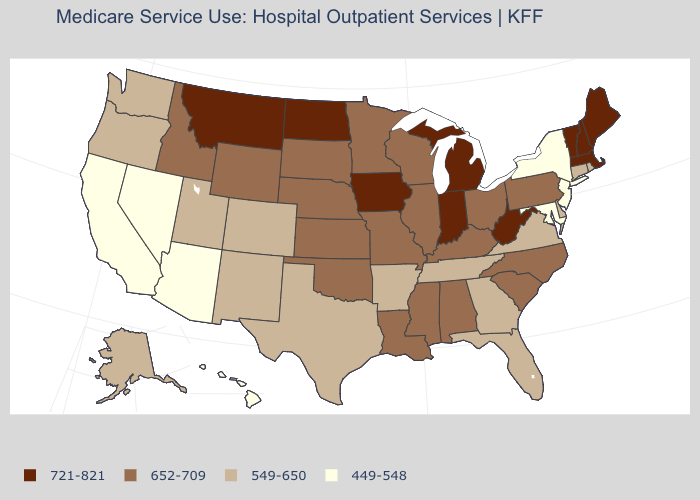Among the states that border Vermont , does New Hampshire have the highest value?
Short answer required. Yes. Does the first symbol in the legend represent the smallest category?
Concise answer only. No. Does New Jersey have a lower value than Washington?
Keep it brief. Yes. Name the states that have a value in the range 549-650?
Write a very short answer. Alaska, Arkansas, Colorado, Connecticut, Delaware, Florida, Georgia, New Mexico, Oregon, Rhode Island, Tennessee, Texas, Utah, Virginia, Washington. What is the lowest value in states that border Missouri?
Keep it brief. 549-650. Among the states that border Indiana , which have the highest value?
Quick response, please. Michigan. Name the states that have a value in the range 549-650?
Answer briefly. Alaska, Arkansas, Colorado, Connecticut, Delaware, Florida, Georgia, New Mexico, Oregon, Rhode Island, Tennessee, Texas, Utah, Virginia, Washington. Name the states that have a value in the range 549-650?
Answer briefly. Alaska, Arkansas, Colorado, Connecticut, Delaware, Florida, Georgia, New Mexico, Oregon, Rhode Island, Tennessee, Texas, Utah, Virginia, Washington. Which states have the lowest value in the USA?
Be succinct. Arizona, California, Hawaii, Maryland, Nevada, New Jersey, New York. What is the value of Florida?
Concise answer only. 549-650. Which states have the lowest value in the South?
Give a very brief answer. Maryland. Which states have the highest value in the USA?
Be succinct. Indiana, Iowa, Maine, Massachusetts, Michigan, Montana, New Hampshire, North Dakota, Vermont, West Virginia. Does the map have missing data?
Keep it brief. No. What is the value of Oklahoma?
Give a very brief answer. 652-709. How many symbols are there in the legend?
Write a very short answer. 4. 